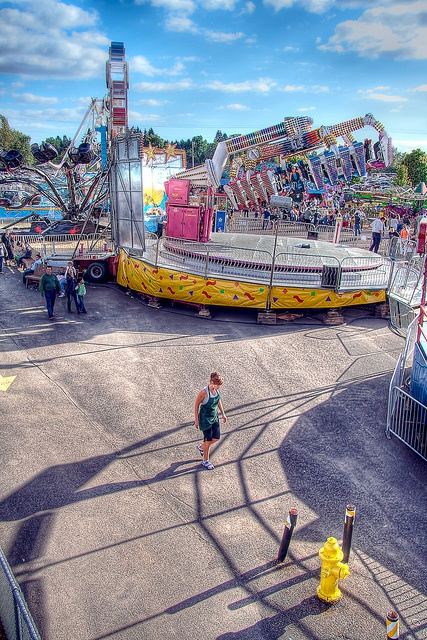Describe the objects in this image and their specific colors. I can see people in lightblue, black, brown, navy, and darkgray tones, fire hydrant in lightblue, orange, gold, khaki, and olive tones, people in lightblue, black, navy, blue, and purple tones, people in lightblue, navy, darkgray, and gray tones, and people in lightblue, black, navy, gray, and blue tones in this image. 